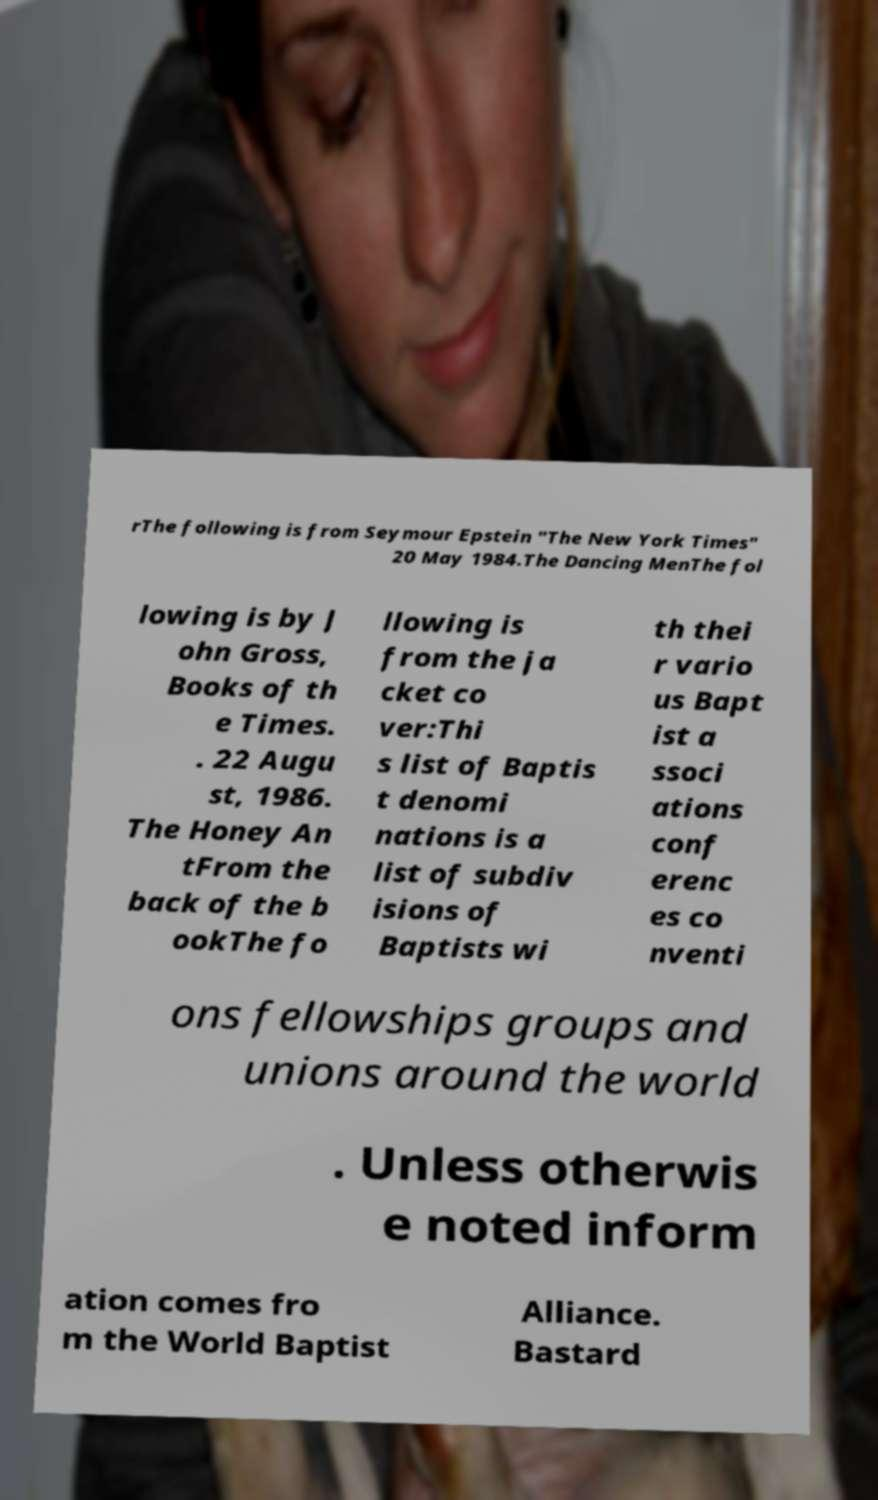Please identify and transcribe the text found in this image. rThe following is from Seymour Epstein "The New York Times" 20 May 1984.The Dancing MenThe fol lowing is by J ohn Gross, Books of th e Times. . 22 Augu st, 1986. The Honey An tFrom the back of the b ookThe fo llowing is from the ja cket co ver:Thi s list of Baptis t denomi nations is a list of subdiv isions of Baptists wi th thei r vario us Bapt ist a ssoci ations conf erenc es co nventi ons fellowships groups and unions around the world . Unless otherwis e noted inform ation comes fro m the World Baptist Alliance. Bastard 